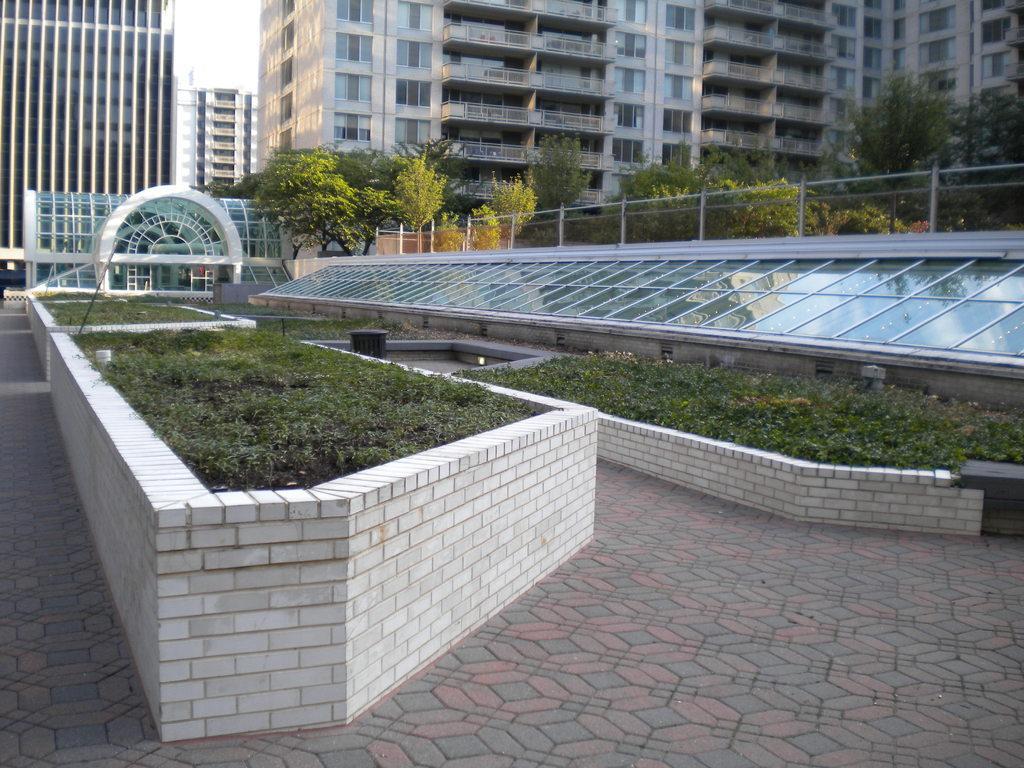In one or two sentences, can you explain what this image depicts? In this image we can see small basement wall in which there are some plants, grass, on right side of the image there is glass wall, trees and in the background of the image there are some buildings and clear sky. 